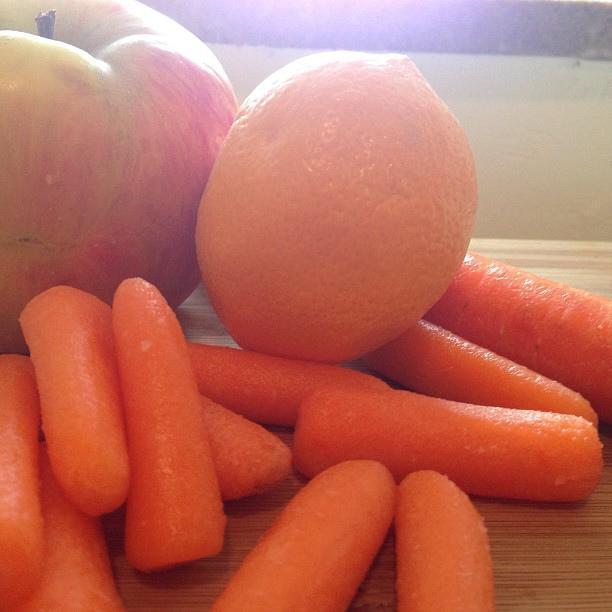Is the given caption "The apple is left of the orange." fitting for the image?
Answer yes or no. Yes. 